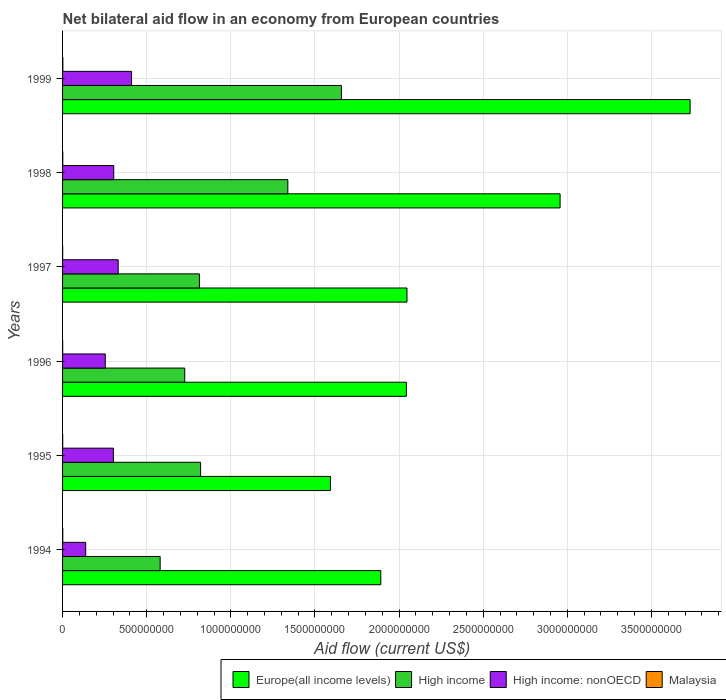Are the number of bars per tick equal to the number of legend labels?
Offer a very short reply. Yes. Are the number of bars on each tick of the Y-axis equal?
Keep it short and to the point. Yes. How many bars are there on the 2nd tick from the top?
Give a very brief answer. 4. What is the label of the 5th group of bars from the top?
Your answer should be very brief. 1995. What is the net bilateral aid flow in Malaysia in 1999?
Make the answer very short. 1.71e+06. Across all years, what is the maximum net bilateral aid flow in Europe(all income levels)?
Provide a short and direct response. 3.73e+09. Across all years, what is the minimum net bilateral aid flow in Europe(all income levels)?
Give a very brief answer. 1.59e+09. In which year was the net bilateral aid flow in High income maximum?
Offer a terse response. 1999. What is the total net bilateral aid flow in Europe(all income levels) in the graph?
Your answer should be compact. 1.43e+1. What is the difference between the net bilateral aid flow in Europe(all income levels) in 1997 and that in 1999?
Your answer should be very brief. -1.68e+09. What is the difference between the net bilateral aid flow in High income: nonOECD in 1994 and the net bilateral aid flow in Malaysia in 1998?
Keep it short and to the point. 1.36e+08. What is the average net bilateral aid flow in Europe(all income levels) per year?
Make the answer very short. 2.38e+09. In the year 1998, what is the difference between the net bilateral aid flow in Malaysia and net bilateral aid flow in Europe(all income levels)?
Give a very brief answer. -2.96e+09. What is the ratio of the net bilateral aid flow in Europe(all income levels) in 1998 to that in 1999?
Provide a succinct answer. 0.79. Is the net bilateral aid flow in High income: nonOECD in 1996 less than that in 1998?
Provide a short and direct response. Yes. Is the difference between the net bilateral aid flow in Malaysia in 1996 and 1999 greater than the difference between the net bilateral aid flow in Europe(all income levels) in 1996 and 1999?
Your answer should be compact. Yes. What is the difference between the highest and the second highest net bilateral aid flow in Europe(all income levels)?
Offer a terse response. 7.73e+08. What is the difference between the highest and the lowest net bilateral aid flow in Europe(all income levels)?
Ensure brevity in your answer.  2.14e+09. Is the sum of the net bilateral aid flow in High income: nonOECD in 1997 and 1999 greater than the maximum net bilateral aid flow in Europe(all income levels) across all years?
Offer a terse response. No. Is it the case that in every year, the sum of the net bilateral aid flow in High income and net bilateral aid flow in Malaysia is greater than the sum of net bilateral aid flow in Europe(all income levels) and net bilateral aid flow in High income: nonOECD?
Provide a succinct answer. No. What does the 4th bar from the top in 1998 represents?
Offer a very short reply. Europe(all income levels). What does the 4th bar from the bottom in 1999 represents?
Make the answer very short. Malaysia. Where does the legend appear in the graph?
Provide a succinct answer. Bottom right. How many legend labels are there?
Provide a short and direct response. 4. What is the title of the graph?
Your response must be concise. Net bilateral aid flow in an economy from European countries. Does "Liberia" appear as one of the legend labels in the graph?
Your response must be concise. No. What is the label or title of the X-axis?
Provide a succinct answer. Aid flow (current US$). What is the label or title of the Y-axis?
Ensure brevity in your answer.  Years. What is the Aid flow (current US$) in Europe(all income levels) in 1994?
Ensure brevity in your answer.  1.89e+09. What is the Aid flow (current US$) of High income in 1994?
Your response must be concise. 5.80e+08. What is the Aid flow (current US$) of High income: nonOECD in 1994?
Provide a succinct answer. 1.37e+08. What is the Aid flow (current US$) in Malaysia in 1994?
Offer a very short reply. 1.26e+06. What is the Aid flow (current US$) in Europe(all income levels) in 1995?
Offer a very short reply. 1.59e+09. What is the Aid flow (current US$) of High income in 1995?
Your answer should be compact. 8.20e+08. What is the Aid flow (current US$) in High income: nonOECD in 1995?
Offer a very short reply. 3.02e+08. What is the Aid flow (current US$) of Malaysia in 1995?
Your answer should be very brief. 7.10e+05. What is the Aid flow (current US$) in Europe(all income levels) in 1996?
Keep it short and to the point. 2.04e+09. What is the Aid flow (current US$) in High income in 1996?
Offer a very short reply. 7.26e+08. What is the Aid flow (current US$) in High income: nonOECD in 1996?
Your answer should be very brief. 2.54e+08. What is the Aid flow (current US$) of Malaysia in 1996?
Offer a very short reply. 5.10e+05. What is the Aid flow (current US$) in Europe(all income levels) in 1997?
Your response must be concise. 2.05e+09. What is the Aid flow (current US$) of High income in 1997?
Your answer should be compact. 8.13e+08. What is the Aid flow (current US$) in High income: nonOECD in 1997?
Keep it short and to the point. 3.30e+08. What is the Aid flow (current US$) of Malaysia in 1997?
Provide a short and direct response. 5.00e+05. What is the Aid flow (current US$) of Europe(all income levels) in 1998?
Your response must be concise. 2.96e+09. What is the Aid flow (current US$) of High income in 1998?
Provide a short and direct response. 1.34e+09. What is the Aid flow (current US$) in High income: nonOECD in 1998?
Your answer should be very brief. 3.04e+08. What is the Aid flow (current US$) in Malaysia in 1998?
Offer a terse response. 1.26e+06. What is the Aid flow (current US$) in Europe(all income levels) in 1999?
Make the answer very short. 3.73e+09. What is the Aid flow (current US$) of High income in 1999?
Your response must be concise. 1.66e+09. What is the Aid flow (current US$) of High income: nonOECD in 1999?
Your response must be concise. 4.10e+08. What is the Aid flow (current US$) in Malaysia in 1999?
Your answer should be compact. 1.71e+06. Across all years, what is the maximum Aid flow (current US$) in Europe(all income levels)?
Provide a short and direct response. 3.73e+09. Across all years, what is the maximum Aid flow (current US$) in High income?
Your answer should be compact. 1.66e+09. Across all years, what is the maximum Aid flow (current US$) in High income: nonOECD?
Offer a very short reply. 4.10e+08. Across all years, what is the maximum Aid flow (current US$) of Malaysia?
Your answer should be compact. 1.71e+06. Across all years, what is the minimum Aid flow (current US$) in Europe(all income levels)?
Provide a succinct answer. 1.59e+09. Across all years, what is the minimum Aid flow (current US$) in High income?
Keep it short and to the point. 5.80e+08. Across all years, what is the minimum Aid flow (current US$) of High income: nonOECD?
Give a very brief answer. 1.37e+08. Across all years, what is the minimum Aid flow (current US$) in Malaysia?
Keep it short and to the point. 5.00e+05. What is the total Aid flow (current US$) of Europe(all income levels) in the graph?
Keep it short and to the point. 1.43e+1. What is the total Aid flow (current US$) in High income in the graph?
Offer a very short reply. 5.94e+09. What is the total Aid flow (current US$) of High income: nonOECD in the graph?
Your answer should be compact. 1.74e+09. What is the total Aid flow (current US$) in Malaysia in the graph?
Keep it short and to the point. 5.95e+06. What is the difference between the Aid flow (current US$) of Europe(all income levels) in 1994 and that in 1995?
Make the answer very short. 2.99e+08. What is the difference between the Aid flow (current US$) in High income in 1994 and that in 1995?
Your answer should be compact. -2.40e+08. What is the difference between the Aid flow (current US$) in High income: nonOECD in 1994 and that in 1995?
Offer a terse response. -1.65e+08. What is the difference between the Aid flow (current US$) of Malaysia in 1994 and that in 1995?
Make the answer very short. 5.50e+05. What is the difference between the Aid flow (current US$) of Europe(all income levels) in 1994 and that in 1996?
Offer a terse response. -1.52e+08. What is the difference between the Aid flow (current US$) of High income in 1994 and that in 1996?
Give a very brief answer. -1.46e+08. What is the difference between the Aid flow (current US$) in High income: nonOECD in 1994 and that in 1996?
Offer a very short reply. -1.16e+08. What is the difference between the Aid flow (current US$) of Malaysia in 1994 and that in 1996?
Make the answer very short. 7.50e+05. What is the difference between the Aid flow (current US$) in Europe(all income levels) in 1994 and that in 1997?
Your response must be concise. -1.56e+08. What is the difference between the Aid flow (current US$) in High income in 1994 and that in 1997?
Keep it short and to the point. -2.33e+08. What is the difference between the Aid flow (current US$) of High income: nonOECD in 1994 and that in 1997?
Ensure brevity in your answer.  -1.93e+08. What is the difference between the Aid flow (current US$) of Malaysia in 1994 and that in 1997?
Provide a succinct answer. 7.60e+05. What is the difference between the Aid flow (current US$) of Europe(all income levels) in 1994 and that in 1998?
Offer a very short reply. -1.07e+09. What is the difference between the Aid flow (current US$) in High income in 1994 and that in 1998?
Your response must be concise. -7.59e+08. What is the difference between the Aid flow (current US$) of High income: nonOECD in 1994 and that in 1998?
Your response must be concise. -1.67e+08. What is the difference between the Aid flow (current US$) in Europe(all income levels) in 1994 and that in 1999?
Ensure brevity in your answer.  -1.84e+09. What is the difference between the Aid flow (current US$) in High income in 1994 and that in 1999?
Your response must be concise. -1.08e+09. What is the difference between the Aid flow (current US$) in High income: nonOECD in 1994 and that in 1999?
Offer a terse response. -2.73e+08. What is the difference between the Aid flow (current US$) of Malaysia in 1994 and that in 1999?
Keep it short and to the point. -4.50e+05. What is the difference between the Aid flow (current US$) in Europe(all income levels) in 1995 and that in 1996?
Offer a terse response. -4.51e+08. What is the difference between the Aid flow (current US$) of High income in 1995 and that in 1996?
Your answer should be compact. 9.42e+07. What is the difference between the Aid flow (current US$) of High income: nonOECD in 1995 and that in 1996?
Keep it short and to the point. 4.82e+07. What is the difference between the Aid flow (current US$) of Europe(all income levels) in 1995 and that in 1997?
Ensure brevity in your answer.  -4.55e+08. What is the difference between the Aid flow (current US$) of High income in 1995 and that in 1997?
Your answer should be compact. 6.92e+06. What is the difference between the Aid flow (current US$) of High income: nonOECD in 1995 and that in 1997?
Ensure brevity in your answer.  -2.86e+07. What is the difference between the Aid flow (current US$) of Malaysia in 1995 and that in 1997?
Your answer should be very brief. 2.10e+05. What is the difference between the Aid flow (current US$) of Europe(all income levels) in 1995 and that in 1998?
Offer a very short reply. -1.36e+09. What is the difference between the Aid flow (current US$) of High income in 1995 and that in 1998?
Your response must be concise. -5.18e+08. What is the difference between the Aid flow (current US$) in High income: nonOECD in 1995 and that in 1998?
Ensure brevity in your answer.  -2.21e+06. What is the difference between the Aid flow (current US$) in Malaysia in 1995 and that in 1998?
Offer a terse response. -5.50e+05. What is the difference between the Aid flow (current US$) in Europe(all income levels) in 1995 and that in 1999?
Your answer should be compact. -2.14e+09. What is the difference between the Aid flow (current US$) in High income in 1995 and that in 1999?
Ensure brevity in your answer.  -8.37e+08. What is the difference between the Aid flow (current US$) in High income: nonOECD in 1995 and that in 1999?
Provide a succinct answer. -1.08e+08. What is the difference between the Aid flow (current US$) of Europe(all income levels) in 1996 and that in 1997?
Keep it short and to the point. -3.69e+06. What is the difference between the Aid flow (current US$) in High income in 1996 and that in 1997?
Your answer should be very brief. -8.72e+07. What is the difference between the Aid flow (current US$) of High income: nonOECD in 1996 and that in 1997?
Provide a succinct answer. -7.67e+07. What is the difference between the Aid flow (current US$) in Malaysia in 1996 and that in 1997?
Keep it short and to the point. 10000. What is the difference between the Aid flow (current US$) in Europe(all income levels) in 1996 and that in 1998?
Provide a short and direct response. -9.14e+08. What is the difference between the Aid flow (current US$) in High income in 1996 and that in 1998?
Keep it short and to the point. -6.13e+08. What is the difference between the Aid flow (current US$) in High income: nonOECD in 1996 and that in 1998?
Provide a succinct answer. -5.04e+07. What is the difference between the Aid flow (current US$) of Malaysia in 1996 and that in 1998?
Keep it short and to the point. -7.50e+05. What is the difference between the Aid flow (current US$) in Europe(all income levels) in 1996 and that in 1999?
Your answer should be very brief. -1.69e+09. What is the difference between the Aid flow (current US$) of High income in 1996 and that in 1999?
Offer a very short reply. -9.31e+08. What is the difference between the Aid flow (current US$) in High income: nonOECD in 1996 and that in 1999?
Offer a very short reply. -1.56e+08. What is the difference between the Aid flow (current US$) of Malaysia in 1996 and that in 1999?
Keep it short and to the point. -1.20e+06. What is the difference between the Aid flow (current US$) of Europe(all income levels) in 1997 and that in 1998?
Ensure brevity in your answer.  -9.10e+08. What is the difference between the Aid flow (current US$) in High income in 1997 and that in 1998?
Make the answer very short. -5.25e+08. What is the difference between the Aid flow (current US$) of High income: nonOECD in 1997 and that in 1998?
Offer a terse response. 2.64e+07. What is the difference between the Aid flow (current US$) in Malaysia in 1997 and that in 1998?
Keep it short and to the point. -7.60e+05. What is the difference between the Aid flow (current US$) in Europe(all income levels) in 1997 and that in 1999?
Your answer should be compact. -1.68e+09. What is the difference between the Aid flow (current US$) of High income in 1997 and that in 1999?
Offer a terse response. -8.44e+08. What is the difference between the Aid flow (current US$) of High income: nonOECD in 1997 and that in 1999?
Give a very brief answer. -7.95e+07. What is the difference between the Aid flow (current US$) of Malaysia in 1997 and that in 1999?
Provide a succinct answer. -1.21e+06. What is the difference between the Aid flow (current US$) of Europe(all income levels) in 1998 and that in 1999?
Provide a succinct answer. -7.73e+08. What is the difference between the Aid flow (current US$) of High income in 1998 and that in 1999?
Your answer should be very brief. -3.18e+08. What is the difference between the Aid flow (current US$) in High income: nonOECD in 1998 and that in 1999?
Offer a very short reply. -1.06e+08. What is the difference between the Aid flow (current US$) in Malaysia in 1998 and that in 1999?
Your answer should be very brief. -4.50e+05. What is the difference between the Aid flow (current US$) in Europe(all income levels) in 1994 and the Aid flow (current US$) in High income in 1995?
Keep it short and to the point. 1.07e+09. What is the difference between the Aid flow (current US$) of Europe(all income levels) in 1994 and the Aid flow (current US$) of High income: nonOECD in 1995?
Give a very brief answer. 1.59e+09. What is the difference between the Aid flow (current US$) in Europe(all income levels) in 1994 and the Aid flow (current US$) in Malaysia in 1995?
Provide a short and direct response. 1.89e+09. What is the difference between the Aid flow (current US$) in High income in 1994 and the Aid flow (current US$) in High income: nonOECD in 1995?
Your answer should be very brief. 2.78e+08. What is the difference between the Aid flow (current US$) of High income in 1994 and the Aid flow (current US$) of Malaysia in 1995?
Offer a terse response. 5.79e+08. What is the difference between the Aid flow (current US$) in High income: nonOECD in 1994 and the Aid flow (current US$) in Malaysia in 1995?
Offer a very short reply. 1.37e+08. What is the difference between the Aid flow (current US$) in Europe(all income levels) in 1994 and the Aid flow (current US$) in High income in 1996?
Ensure brevity in your answer.  1.17e+09. What is the difference between the Aid flow (current US$) in Europe(all income levels) in 1994 and the Aid flow (current US$) in High income: nonOECD in 1996?
Offer a terse response. 1.64e+09. What is the difference between the Aid flow (current US$) of Europe(all income levels) in 1994 and the Aid flow (current US$) of Malaysia in 1996?
Offer a terse response. 1.89e+09. What is the difference between the Aid flow (current US$) in High income in 1994 and the Aid flow (current US$) in High income: nonOECD in 1996?
Your response must be concise. 3.26e+08. What is the difference between the Aid flow (current US$) of High income in 1994 and the Aid flow (current US$) of Malaysia in 1996?
Provide a succinct answer. 5.79e+08. What is the difference between the Aid flow (current US$) in High income: nonOECD in 1994 and the Aid flow (current US$) in Malaysia in 1996?
Offer a terse response. 1.37e+08. What is the difference between the Aid flow (current US$) of Europe(all income levels) in 1994 and the Aid flow (current US$) of High income in 1997?
Provide a short and direct response. 1.08e+09. What is the difference between the Aid flow (current US$) of Europe(all income levels) in 1994 and the Aid flow (current US$) of High income: nonOECD in 1997?
Offer a very short reply. 1.56e+09. What is the difference between the Aid flow (current US$) in Europe(all income levels) in 1994 and the Aid flow (current US$) in Malaysia in 1997?
Your response must be concise. 1.89e+09. What is the difference between the Aid flow (current US$) of High income in 1994 and the Aid flow (current US$) of High income: nonOECD in 1997?
Your response must be concise. 2.50e+08. What is the difference between the Aid flow (current US$) in High income in 1994 and the Aid flow (current US$) in Malaysia in 1997?
Offer a very short reply. 5.80e+08. What is the difference between the Aid flow (current US$) of High income: nonOECD in 1994 and the Aid flow (current US$) of Malaysia in 1997?
Your answer should be compact. 1.37e+08. What is the difference between the Aid flow (current US$) in Europe(all income levels) in 1994 and the Aid flow (current US$) in High income in 1998?
Offer a terse response. 5.52e+08. What is the difference between the Aid flow (current US$) in Europe(all income levels) in 1994 and the Aid flow (current US$) in High income: nonOECD in 1998?
Offer a very short reply. 1.59e+09. What is the difference between the Aid flow (current US$) of Europe(all income levels) in 1994 and the Aid flow (current US$) of Malaysia in 1998?
Keep it short and to the point. 1.89e+09. What is the difference between the Aid flow (current US$) of High income in 1994 and the Aid flow (current US$) of High income: nonOECD in 1998?
Make the answer very short. 2.76e+08. What is the difference between the Aid flow (current US$) in High income in 1994 and the Aid flow (current US$) in Malaysia in 1998?
Your response must be concise. 5.79e+08. What is the difference between the Aid flow (current US$) in High income: nonOECD in 1994 and the Aid flow (current US$) in Malaysia in 1998?
Provide a succinct answer. 1.36e+08. What is the difference between the Aid flow (current US$) of Europe(all income levels) in 1994 and the Aid flow (current US$) of High income in 1999?
Ensure brevity in your answer.  2.34e+08. What is the difference between the Aid flow (current US$) of Europe(all income levels) in 1994 and the Aid flow (current US$) of High income: nonOECD in 1999?
Make the answer very short. 1.48e+09. What is the difference between the Aid flow (current US$) in Europe(all income levels) in 1994 and the Aid flow (current US$) in Malaysia in 1999?
Give a very brief answer. 1.89e+09. What is the difference between the Aid flow (current US$) in High income in 1994 and the Aid flow (current US$) in High income: nonOECD in 1999?
Keep it short and to the point. 1.70e+08. What is the difference between the Aid flow (current US$) of High income in 1994 and the Aid flow (current US$) of Malaysia in 1999?
Give a very brief answer. 5.78e+08. What is the difference between the Aid flow (current US$) in High income: nonOECD in 1994 and the Aid flow (current US$) in Malaysia in 1999?
Offer a very short reply. 1.36e+08. What is the difference between the Aid flow (current US$) of Europe(all income levels) in 1995 and the Aid flow (current US$) of High income in 1996?
Make the answer very short. 8.66e+08. What is the difference between the Aid flow (current US$) of Europe(all income levels) in 1995 and the Aid flow (current US$) of High income: nonOECD in 1996?
Make the answer very short. 1.34e+09. What is the difference between the Aid flow (current US$) in Europe(all income levels) in 1995 and the Aid flow (current US$) in Malaysia in 1996?
Keep it short and to the point. 1.59e+09. What is the difference between the Aid flow (current US$) in High income in 1995 and the Aid flow (current US$) in High income: nonOECD in 1996?
Keep it short and to the point. 5.67e+08. What is the difference between the Aid flow (current US$) of High income in 1995 and the Aid flow (current US$) of Malaysia in 1996?
Offer a very short reply. 8.20e+08. What is the difference between the Aid flow (current US$) of High income: nonOECD in 1995 and the Aid flow (current US$) of Malaysia in 1996?
Offer a terse response. 3.01e+08. What is the difference between the Aid flow (current US$) of Europe(all income levels) in 1995 and the Aid flow (current US$) of High income in 1997?
Provide a succinct answer. 7.79e+08. What is the difference between the Aid flow (current US$) in Europe(all income levels) in 1995 and the Aid flow (current US$) in High income: nonOECD in 1997?
Provide a succinct answer. 1.26e+09. What is the difference between the Aid flow (current US$) of Europe(all income levels) in 1995 and the Aid flow (current US$) of Malaysia in 1997?
Keep it short and to the point. 1.59e+09. What is the difference between the Aid flow (current US$) of High income in 1995 and the Aid flow (current US$) of High income: nonOECD in 1997?
Your answer should be very brief. 4.90e+08. What is the difference between the Aid flow (current US$) in High income in 1995 and the Aid flow (current US$) in Malaysia in 1997?
Offer a terse response. 8.20e+08. What is the difference between the Aid flow (current US$) of High income: nonOECD in 1995 and the Aid flow (current US$) of Malaysia in 1997?
Provide a succinct answer. 3.01e+08. What is the difference between the Aid flow (current US$) in Europe(all income levels) in 1995 and the Aid flow (current US$) in High income in 1998?
Offer a terse response. 2.53e+08. What is the difference between the Aid flow (current US$) of Europe(all income levels) in 1995 and the Aid flow (current US$) of High income: nonOECD in 1998?
Provide a short and direct response. 1.29e+09. What is the difference between the Aid flow (current US$) in Europe(all income levels) in 1995 and the Aid flow (current US$) in Malaysia in 1998?
Your response must be concise. 1.59e+09. What is the difference between the Aid flow (current US$) in High income in 1995 and the Aid flow (current US$) in High income: nonOECD in 1998?
Ensure brevity in your answer.  5.16e+08. What is the difference between the Aid flow (current US$) of High income in 1995 and the Aid flow (current US$) of Malaysia in 1998?
Keep it short and to the point. 8.19e+08. What is the difference between the Aid flow (current US$) of High income: nonOECD in 1995 and the Aid flow (current US$) of Malaysia in 1998?
Ensure brevity in your answer.  3.01e+08. What is the difference between the Aid flow (current US$) in Europe(all income levels) in 1995 and the Aid flow (current US$) in High income in 1999?
Your answer should be compact. -6.51e+07. What is the difference between the Aid flow (current US$) in Europe(all income levels) in 1995 and the Aid flow (current US$) in High income: nonOECD in 1999?
Provide a short and direct response. 1.18e+09. What is the difference between the Aid flow (current US$) of Europe(all income levels) in 1995 and the Aid flow (current US$) of Malaysia in 1999?
Provide a succinct answer. 1.59e+09. What is the difference between the Aid flow (current US$) in High income in 1995 and the Aid flow (current US$) in High income: nonOECD in 1999?
Make the answer very short. 4.10e+08. What is the difference between the Aid flow (current US$) of High income in 1995 and the Aid flow (current US$) of Malaysia in 1999?
Offer a terse response. 8.19e+08. What is the difference between the Aid flow (current US$) in High income: nonOECD in 1995 and the Aid flow (current US$) in Malaysia in 1999?
Your answer should be very brief. 3.00e+08. What is the difference between the Aid flow (current US$) in Europe(all income levels) in 1996 and the Aid flow (current US$) in High income in 1997?
Make the answer very short. 1.23e+09. What is the difference between the Aid flow (current US$) of Europe(all income levels) in 1996 and the Aid flow (current US$) of High income: nonOECD in 1997?
Ensure brevity in your answer.  1.71e+09. What is the difference between the Aid flow (current US$) of Europe(all income levels) in 1996 and the Aid flow (current US$) of Malaysia in 1997?
Provide a short and direct response. 2.04e+09. What is the difference between the Aid flow (current US$) of High income in 1996 and the Aid flow (current US$) of High income: nonOECD in 1997?
Your answer should be very brief. 3.96e+08. What is the difference between the Aid flow (current US$) of High income in 1996 and the Aid flow (current US$) of Malaysia in 1997?
Give a very brief answer. 7.26e+08. What is the difference between the Aid flow (current US$) of High income: nonOECD in 1996 and the Aid flow (current US$) of Malaysia in 1997?
Provide a succinct answer. 2.53e+08. What is the difference between the Aid flow (current US$) of Europe(all income levels) in 1996 and the Aid flow (current US$) of High income in 1998?
Your answer should be compact. 7.05e+08. What is the difference between the Aid flow (current US$) in Europe(all income levels) in 1996 and the Aid flow (current US$) in High income: nonOECD in 1998?
Ensure brevity in your answer.  1.74e+09. What is the difference between the Aid flow (current US$) of Europe(all income levels) in 1996 and the Aid flow (current US$) of Malaysia in 1998?
Your answer should be compact. 2.04e+09. What is the difference between the Aid flow (current US$) in High income in 1996 and the Aid flow (current US$) in High income: nonOECD in 1998?
Your response must be concise. 4.22e+08. What is the difference between the Aid flow (current US$) of High income in 1996 and the Aid flow (current US$) of Malaysia in 1998?
Your answer should be very brief. 7.25e+08. What is the difference between the Aid flow (current US$) of High income: nonOECD in 1996 and the Aid flow (current US$) of Malaysia in 1998?
Your answer should be very brief. 2.53e+08. What is the difference between the Aid flow (current US$) of Europe(all income levels) in 1996 and the Aid flow (current US$) of High income in 1999?
Ensure brevity in your answer.  3.86e+08. What is the difference between the Aid flow (current US$) in Europe(all income levels) in 1996 and the Aid flow (current US$) in High income: nonOECD in 1999?
Provide a succinct answer. 1.63e+09. What is the difference between the Aid flow (current US$) in Europe(all income levels) in 1996 and the Aid flow (current US$) in Malaysia in 1999?
Your answer should be compact. 2.04e+09. What is the difference between the Aid flow (current US$) in High income in 1996 and the Aid flow (current US$) in High income: nonOECD in 1999?
Keep it short and to the point. 3.16e+08. What is the difference between the Aid flow (current US$) of High income in 1996 and the Aid flow (current US$) of Malaysia in 1999?
Your answer should be compact. 7.24e+08. What is the difference between the Aid flow (current US$) of High income: nonOECD in 1996 and the Aid flow (current US$) of Malaysia in 1999?
Your answer should be very brief. 2.52e+08. What is the difference between the Aid flow (current US$) in Europe(all income levels) in 1997 and the Aid flow (current US$) in High income in 1998?
Keep it short and to the point. 7.08e+08. What is the difference between the Aid flow (current US$) of Europe(all income levels) in 1997 and the Aid flow (current US$) of High income: nonOECD in 1998?
Keep it short and to the point. 1.74e+09. What is the difference between the Aid flow (current US$) in Europe(all income levels) in 1997 and the Aid flow (current US$) in Malaysia in 1998?
Provide a short and direct response. 2.05e+09. What is the difference between the Aid flow (current US$) in High income in 1997 and the Aid flow (current US$) in High income: nonOECD in 1998?
Offer a terse response. 5.09e+08. What is the difference between the Aid flow (current US$) of High income in 1997 and the Aid flow (current US$) of Malaysia in 1998?
Give a very brief answer. 8.12e+08. What is the difference between the Aid flow (current US$) of High income: nonOECD in 1997 and the Aid flow (current US$) of Malaysia in 1998?
Provide a short and direct response. 3.29e+08. What is the difference between the Aid flow (current US$) in Europe(all income levels) in 1997 and the Aid flow (current US$) in High income in 1999?
Keep it short and to the point. 3.90e+08. What is the difference between the Aid flow (current US$) of Europe(all income levels) in 1997 and the Aid flow (current US$) of High income: nonOECD in 1999?
Your response must be concise. 1.64e+09. What is the difference between the Aid flow (current US$) in Europe(all income levels) in 1997 and the Aid flow (current US$) in Malaysia in 1999?
Your response must be concise. 2.05e+09. What is the difference between the Aid flow (current US$) of High income in 1997 and the Aid flow (current US$) of High income: nonOECD in 1999?
Provide a short and direct response. 4.03e+08. What is the difference between the Aid flow (current US$) in High income in 1997 and the Aid flow (current US$) in Malaysia in 1999?
Provide a succinct answer. 8.12e+08. What is the difference between the Aid flow (current US$) in High income: nonOECD in 1997 and the Aid flow (current US$) in Malaysia in 1999?
Your answer should be very brief. 3.29e+08. What is the difference between the Aid flow (current US$) in Europe(all income levels) in 1998 and the Aid flow (current US$) in High income in 1999?
Your answer should be very brief. 1.30e+09. What is the difference between the Aid flow (current US$) in Europe(all income levels) in 1998 and the Aid flow (current US$) in High income: nonOECD in 1999?
Offer a very short reply. 2.55e+09. What is the difference between the Aid flow (current US$) of Europe(all income levels) in 1998 and the Aid flow (current US$) of Malaysia in 1999?
Offer a terse response. 2.96e+09. What is the difference between the Aid flow (current US$) in High income in 1998 and the Aid flow (current US$) in High income: nonOECD in 1999?
Your answer should be very brief. 9.29e+08. What is the difference between the Aid flow (current US$) in High income in 1998 and the Aid flow (current US$) in Malaysia in 1999?
Your answer should be compact. 1.34e+09. What is the difference between the Aid flow (current US$) of High income: nonOECD in 1998 and the Aid flow (current US$) of Malaysia in 1999?
Make the answer very short. 3.02e+08. What is the average Aid flow (current US$) of Europe(all income levels) per year?
Offer a terse response. 2.38e+09. What is the average Aid flow (current US$) of High income per year?
Keep it short and to the point. 9.89e+08. What is the average Aid flow (current US$) in High income: nonOECD per year?
Keep it short and to the point. 2.90e+08. What is the average Aid flow (current US$) in Malaysia per year?
Keep it short and to the point. 9.92e+05. In the year 1994, what is the difference between the Aid flow (current US$) of Europe(all income levels) and Aid flow (current US$) of High income?
Your answer should be very brief. 1.31e+09. In the year 1994, what is the difference between the Aid flow (current US$) of Europe(all income levels) and Aid flow (current US$) of High income: nonOECD?
Offer a very short reply. 1.75e+09. In the year 1994, what is the difference between the Aid flow (current US$) of Europe(all income levels) and Aid flow (current US$) of Malaysia?
Keep it short and to the point. 1.89e+09. In the year 1994, what is the difference between the Aid flow (current US$) of High income and Aid flow (current US$) of High income: nonOECD?
Give a very brief answer. 4.43e+08. In the year 1994, what is the difference between the Aid flow (current US$) of High income and Aid flow (current US$) of Malaysia?
Your answer should be very brief. 5.79e+08. In the year 1994, what is the difference between the Aid flow (current US$) of High income: nonOECD and Aid flow (current US$) of Malaysia?
Ensure brevity in your answer.  1.36e+08. In the year 1995, what is the difference between the Aid flow (current US$) in Europe(all income levels) and Aid flow (current US$) in High income?
Make the answer very short. 7.72e+08. In the year 1995, what is the difference between the Aid flow (current US$) of Europe(all income levels) and Aid flow (current US$) of High income: nonOECD?
Provide a short and direct response. 1.29e+09. In the year 1995, what is the difference between the Aid flow (current US$) in Europe(all income levels) and Aid flow (current US$) in Malaysia?
Offer a very short reply. 1.59e+09. In the year 1995, what is the difference between the Aid flow (current US$) of High income and Aid flow (current US$) of High income: nonOECD?
Offer a terse response. 5.18e+08. In the year 1995, what is the difference between the Aid flow (current US$) of High income and Aid flow (current US$) of Malaysia?
Offer a very short reply. 8.20e+08. In the year 1995, what is the difference between the Aid flow (current US$) in High income: nonOECD and Aid flow (current US$) in Malaysia?
Your answer should be compact. 3.01e+08. In the year 1996, what is the difference between the Aid flow (current US$) of Europe(all income levels) and Aid flow (current US$) of High income?
Keep it short and to the point. 1.32e+09. In the year 1996, what is the difference between the Aid flow (current US$) of Europe(all income levels) and Aid flow (current US$) of High income: nonOECD?
Ensure brevity in your answer.  1.79e+09. In the year 1996, what is the difference between the Aid flow (current US$) in Europe(all income levels) and Aid flow (current US$) in Malaysia?
Ensure brevity in your answer.  2.04e+09. In the year 1996, what is the difference between the Aid flow (current US$) in High income and Aid flow (current US$) in High income: nonOECD?
Give a very brief answer. 4.72e+08. In the year 1996, what is the difference between the Aid flow (current US$) in High income and Aid flow (current US$) in Malaysia?
Give a very brief answer. 7.26e+08. In the year 1996, what is the difference between the Aid flow (current US$) of High income: nonOECD and Aid flow (current US$) of Malaysia?
Your answer should be very brief. 2.53e+08. In the year 1997, what is the difference between the Aid flow (current US$) of Europe(all income levels) and Aid flow (current US$) of High income?
Ensure brevity in your answer.  1.23e+09. In the year 1997, what is the difference between the Aid flow (current US$) in Europe(all income levels) and Aid flow (current US$) in High income: nonOECD?
Give a very brief answer. 1.72e+09. In the year 1997, what is the difference between the Aid flow (current US$) in Europe(all income levels) and Aid flow (current US$) in Malaysia?
Offer a terse response. 2.05e+09. In the year 1997, what is the difference between the Aid flow (current US$) of High income and Aid flow (current US$) of High income: nonOECD?
Your response must be concise. 4.83e+08. In the year 1997, what is the difference between the Aid flow (current US$) of High income and Aid flow (current US$) of Malaysia?
Your answer should be compact. 8.13e+08. In the year 1997, what is the difference between the Aid flow (current US$) of High income: nonOECD and Aid flow (current US$) of Malaysia?
Offer a very short reply. 3.30e+08. In the year 1998, what is the difference between the Aid flow (current US$) in Europe(all income levels) and Aid flow (current US$) in High income?
Ensure brevity in your answer.  1.62e+09. In the year 1998, what is the difference between the Aid flow (current US$) of Europe(all income levels) and Aid flow (current US$) of High income: nonOECD?
Keep it short and to the point. 2.65e+09. In the year 1998, what is the difference between the Aid flow (current US$) of Europe(all income levels) and Aid flow (current US$) of Malaysia?
Provide a succinct answer. 2.96e+09. In the year 1998, what is the difference between the Aid flow (current US$) in High income and Aid flow (current US$) in High income: nonOECD?
Ensure brevity in your answer.  1.03e+09. In the year 1998, what is the difference between the Aid flow (current US$) of High income and Aid flow (current US$) of Malaysia?
Your answer should be very brief. 1.34e+09. In the year 1998, what is the difference between the Aid flow (current US$) in High income: nonOECD and Aid flow (current US$) in Malaysia?
Provide a succinct answer. 3.03e+08. In the year 1999, what is the difference between the Aid flow (current US$) of Europe(all income levels) and Aid flow (current US$) of High income?
Ensure brevity in your answer.  2.07e+09. In the year 1999, what is the difference between the Aid flow (current US$) in Europe(all income levels) and Aid flow (current US$) in High income: nonOECD?
Your answer should be compact. 3.32e+09. In the year 1999, what is the difference between the Aid flow (current US$) of Europe(all income levels) and Aid flow (current US$) of Malaysia?
Your answer should be compact. 3.73e+09. In the year 1999, what is the difference between the Aid flow (current US$) of High income and Aid flow (current US$) of High income: nonOECD?
Make the answer very short. 1.25e+09. In the year 1999, what is the difference between the Aid flow (current US$) in High income and Aid flow (current US$) in Malaysia?
Give a very brief answer. 1.66e+09. In the year 1999, what is the difference between the Aid flow (current US$) of High income: nonOECD and Aid flow (current US$) of Malaysia?
Ensure brevity in your answer.  4.08e+08. What is the ratio of the Aid flow (current US$) of Europe(all income levels) in 1994 to that in 1995?
Your response must be concise. 1.19. What is the ratio of the Aid flow (current US$) of High income in 1994 to that in 1995?
Ensure brevity in your answer.  0.71. What is the ratio of the Aid flow (current US$) of High income: nonOECD in 1994 to that in 1995?
Keep it short and to the point. 0.45. What is the ratio of the Aid flow (current US$) in Malaysia in 1994 to that in 1995?
Your answer should be compact. 1.77. What is the ratio of the Aid flow (current US$) of Europe(all income levels) in 1994 to that in 1996?
Ensure brevity in your answer.  0.93. What is the ratio of the Aid flow (current US$) in High income in 1994 to that in 1996?
Offer a very short reply. 0.8. What is the ratio of the Aid flow (current US$) in High income: nonOECD in 1994 to that in 1996?
Offer a terse response. 0.54. What is the ratio of the Aid flow (current US$) in Malaysia in 1994 to that in 1996?
Give a very brief answer. 2.47. What is the ratio of the Aid flow (current US$) in Europe(all income levels) in 1994 to that in 1997?
Give a very brief answer. 0.92. What is the ratio of the Aid flow (current US$) in High income in 1994 to that in 1997?
Offer a terse response. 0.71. What is the ratio of the Aid flow (current US$) of High income: nonOECD in 1994 to that in 1997?
Offer a terse response. 0.42. What is the ratio of the Aid flow (current US$) of Malaysia in 1994 to that in 1997?
Provide a succinct answer. 2.52. What is the ratio of the Aid flow (current US$) in Europe(all income levels) in 1994 to that in 1998?
Provide a short and direct response. 0.64. What is the ratio of the Aid flow (current US$) in High income in 1994 to that in 1998?
Your answer should be compact. 0.43. What is the ratio of the Aid flow (current US$) of High income: nonOECD in 1994 to that in 1998?
Give a very brief answer. 0.45. What is the ratio of the Aid flow (current US$) of Malaysia in 1994 to that in 1998?
Ensure brevity in your answer.  1. What is the ratio of the Aid flow (current US$) of Europe(all income levels) in 1994 to that in 1999?
Offer a very short reply. 0.51. What is the ratio of the Aid flow (current US$) in High income: nonOECD in 1994 to that in 1999?
Provide a short and direct response. 0.33. What is the ratio of the Aid flow (current US$) of Malaysia in 1994 to that in 1999?
Ensure brevity in your answer.  0.74. What is the ratio of the Aid flow (current US$) in Europe(all income levels) in 1995 to that in 1996?
Ensure brevity in your answer.  0.78. What is the ratio of the Aid flow (current US$) in High income in 1995 to that in 1996?
Offer a terse response. 1.13. What is the ratio of the Aid flow (current US$) in High income: nonOECD in 1995 to that in 1996?
Ensure brevity in your answer.  1.19. What is the ratio of the Aid flow (current US$) in Malaysia in 1995 to that in 1996?
Give a very brief answer. 1.39. What is the ratio of the Aid flow (current US$) of Europe(all income levels) in 1995 to that in 1997?
Your response must be concise. 0.78. What is the ratio of the Aid flow (current US$) of High income in 1995 to that in 1997?
Give a very brief answer. 1.01. What is the ratio of the Aid flow (current US$) of High income: nonOECD in 1995 to that in 1997?
Your answer should be very brief. 0.91. What is the ratio of the Aid flow (current US$) of Malaysia in 1995 to that in 1997?
Provide a succinct answer. 1.42. What is the ratio of the Aid flow (current US$) in Europe(all income levels) in 1995 to that in 1998?
Give a very brief answer. 0.54. What is the ratio of the Aid flow (current US$) in High income in 1995 to that in 1998?
Your answer should be compact. 0.61. What is the ratio of the Aid flow (current US$) of Malaysia in 1995 to that in 1998?
Keep it short and to the point. 0.56. What is the ratio of the Aid flow (current US$) in Europe(all income levels) in 1995 to that in 1999?
Your response must be concise. 0.43. What is the ratio of the Aid flow (current US$) of High income in 1995 to that in 1999?
Provide a short and direct response. 0.49. What is the ratio of the Aid flow (current US$) in High income: nonOECD in 1995 to that in 1999?
Ensure brevity in your answer.  0.74. What is the ratio of the Aid flow (current US$) in Malaysia in 1995 to that in 1999?
Give a very brief answer. 0.42. What is the ratio of the Aid flow (current US$) in High income in 1996 to that in 1997?
Your response must be concise. 0.89. What is the ratio of the Aid flow (current US$) of High income: nonOECD in 1996 to that in 1997?
Make the answer very short. 0.77. What is the ratio of the Aid flow (current US$) of Malaysia in 1996 to that in 1997?
Provide a succinct answer. 1.02. What is the ratio of the Aid flow (current US$) of Europe(all income levels) in 1996 to that in 1998?
Make the answer very short. 0.69. What is the ratio of the Aid flow (current US$) in High income in 1996 to that in 1998?
Your answer should be very brief. 0.54. What is the ratio of the Aid flow (current US$) of High income: nonOECD in 1996 to that in 1998?
Offer a very short reply. 0.83. What is the ratio of the Aid flow (current US$) in Malaysia in 1996 to that in 1998?
Offer a very short reply. 0.4. What is the ratio of the Aid flow (current US$) in Europe(all income levels) in 1996 to that in 1999?
Give a very brief answer. 0.55. What is the ratio of the Aid flow (current US$) in High income in 1996 to that in 1999?
Provide a succinct answer. 0.44. What is the ratio of the Aid flow (current US$) in High income: nonOECD in 1996 to that in 1999?
Offer a terse response. 0.62. What is the ratio of the Aid flow (current US$) in Malaysia in 1996 to that in 1999?
Ensure brevity in your answer.  0.3. What is the ratio of the Aid flow (current US$) of Europe(all income levels) in 1997 to that in 1998?
Offer a very short reply. 0.69. What is the ratio of the Aid flow (current US$) in High income in 1997 to that in 1998?
Offer a very short reply. 0.61. What is the ratio of the Aid flow (current US$) of High income: nonOECD in 1997 to that in 1998?
Your response must be concise. 1.09. What is the ratio of the Aid flow (current US$) of Malaysia in 1997 to that in 1998?
Offer a terse response. 0.4. What is the ratio of the Aid flow (current US$) in Europe(all income levels) in 1997 to that in 1999?
Ensure brevity in your answer.  0.55. What is the ratio of the Aid flow (current US$) of High income in 1997 to that in 1999?
Your response must be concise. 0.49. What is the ratio of the Aid flow (current US$) of High income: nonOECD in 1997 to that in 1999?
Keep it short and to the point. 0.81. What is the ratio of the Aid flow (current US$) in Malaysia in 1997 to that in 1999?
Offer a terse response. 0.29. What is the ratio of the Aid flow (current US$) in Europe(all income levels) in 1998 to that in 1999?
Your response must be concise. 0.79. What is the ratio of the Aid flow (current US$) of High income in 1998 to that in 1999?
Offer a terse response. 0.81. What is the ratio of the Aid flow (current US$) in High income: nonOECD in 1998 to that in 1999?
Make the answer very short. 0.74. What is the ratio of the Aid flow (current US$) in Malaysia in 1998 to that in 1999?
Your answer should be very brief. 0.74. What is the difference between the highest and the second highest Aid flow (current US$) in Europe(all income levels)?
Ensure brevity in your answer.  7.73e+08. What is the difference between the highest and the second highest Aid flow (current US$) in High income?
Give a very brief answer. 3.18e+08. What is the difference between the highest and the second highest Aid flow (current US$) of High income: nonOECD?
Keep it short and to the point. 7.95e+07. What is the difference between the highest and the second highest Aid flow (current US$) in Malaysia?
Your response must be concise. 4.50e+05. What is the difference between the highest and the lowest Aid flow (current US$) in Europe(all income levels)?
Offer a very short reply. 2.14e+09. What is the difference between the highest and the lowest Aid flow (current US$) of High income?
Provide a short and direct response. 1.08e+09. What is the difference between the highest and the lowest Aid flow (current US$) of High income: nonOECD?
Offer a terse response. 2.73e+08. What is the difference between the highest and the lowest Aid flow (current US$) in Malaysia?
Provide a short and direct response. 1.21e+06. 